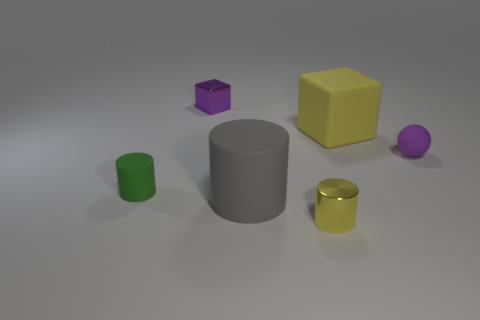Add 1 big blue rubber balls. How many objects exist? 7 Subtract all blocks. How many objects are left? 4 Subtract all purple metallic objects. Subtract all rubber cylinders. How many objects are left? 3 Add 4 gray things. How many gray things are left? 5 Add 3 large green cylinders. How many large green cylinders exist? 3 Subtract 0 purple cylinders. How many objects are left? 6 